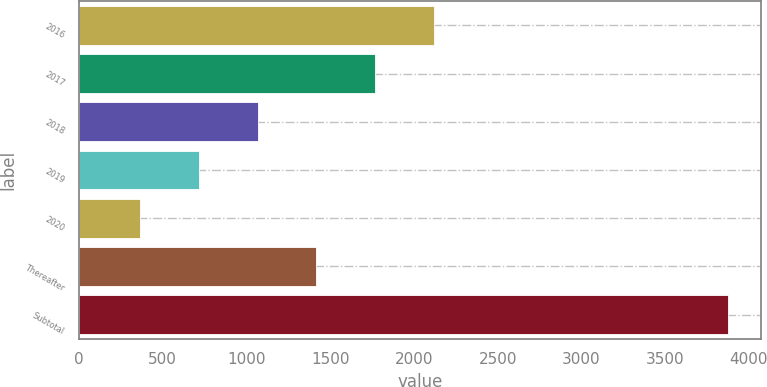Convert chart. <chart><loc_0><loc_0><loc_500><loc_500><bar_chart><fcel>2016<fcel>2017<fcel>2018<fcel>2019<fcel>2020<fcel>Thereafter<fcel>Subtotal<nl><fcel>2120.5<fcel>1769.4<fcel>1067.2<fcel>716.1<fcel>365<fcel>1418.3<fcel>3876<nl></chart> 